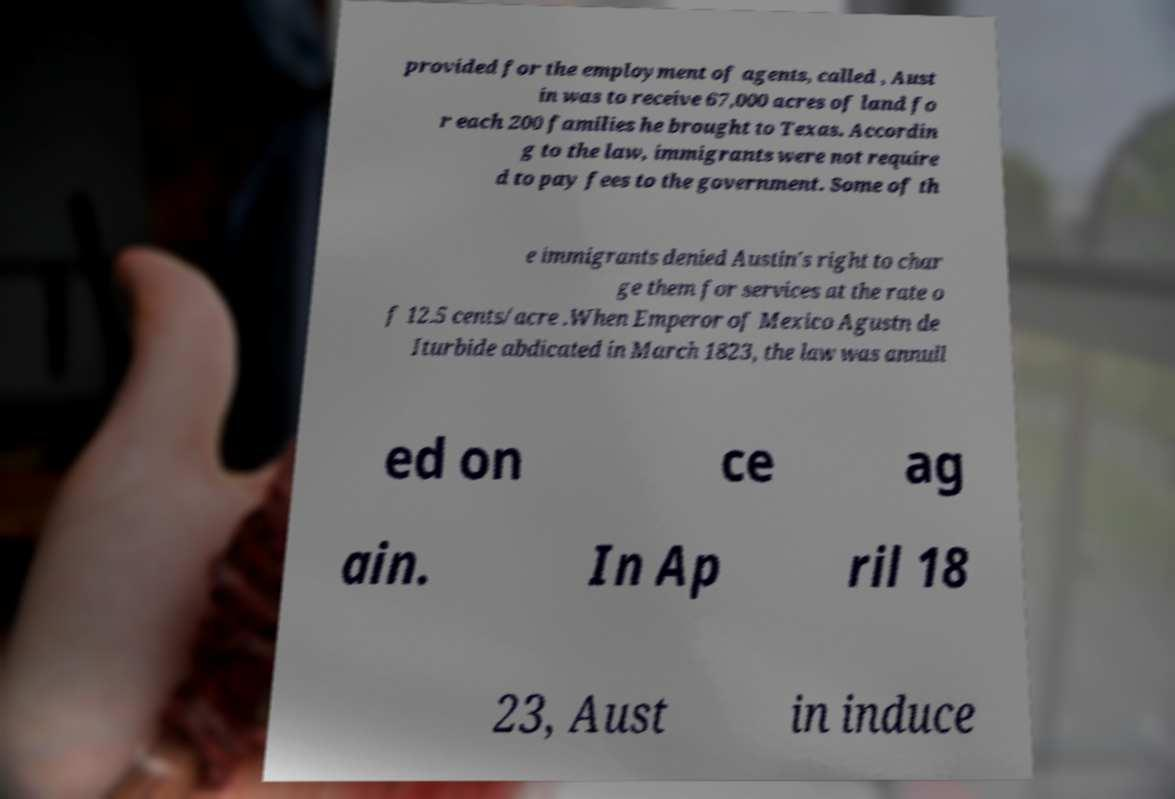Can you accurately transcribe the text from the provided image for me? provided for the employment of agents, called , Aust in was to receive 67,000 acres of land fo r each 200 families he brought to Texas. Accordin g to the law, immigrants were not require d to pay fees to the government. Some of th e immigrants denied Austin's right to char ge them for services at the rate o f 12.5 cents/acre .When Emperor of Mexico Agustn de Iturbide abdicated in March 1823, the law was annull ed on ce ag ain. In Ap ril 18 23, Aust in induce 